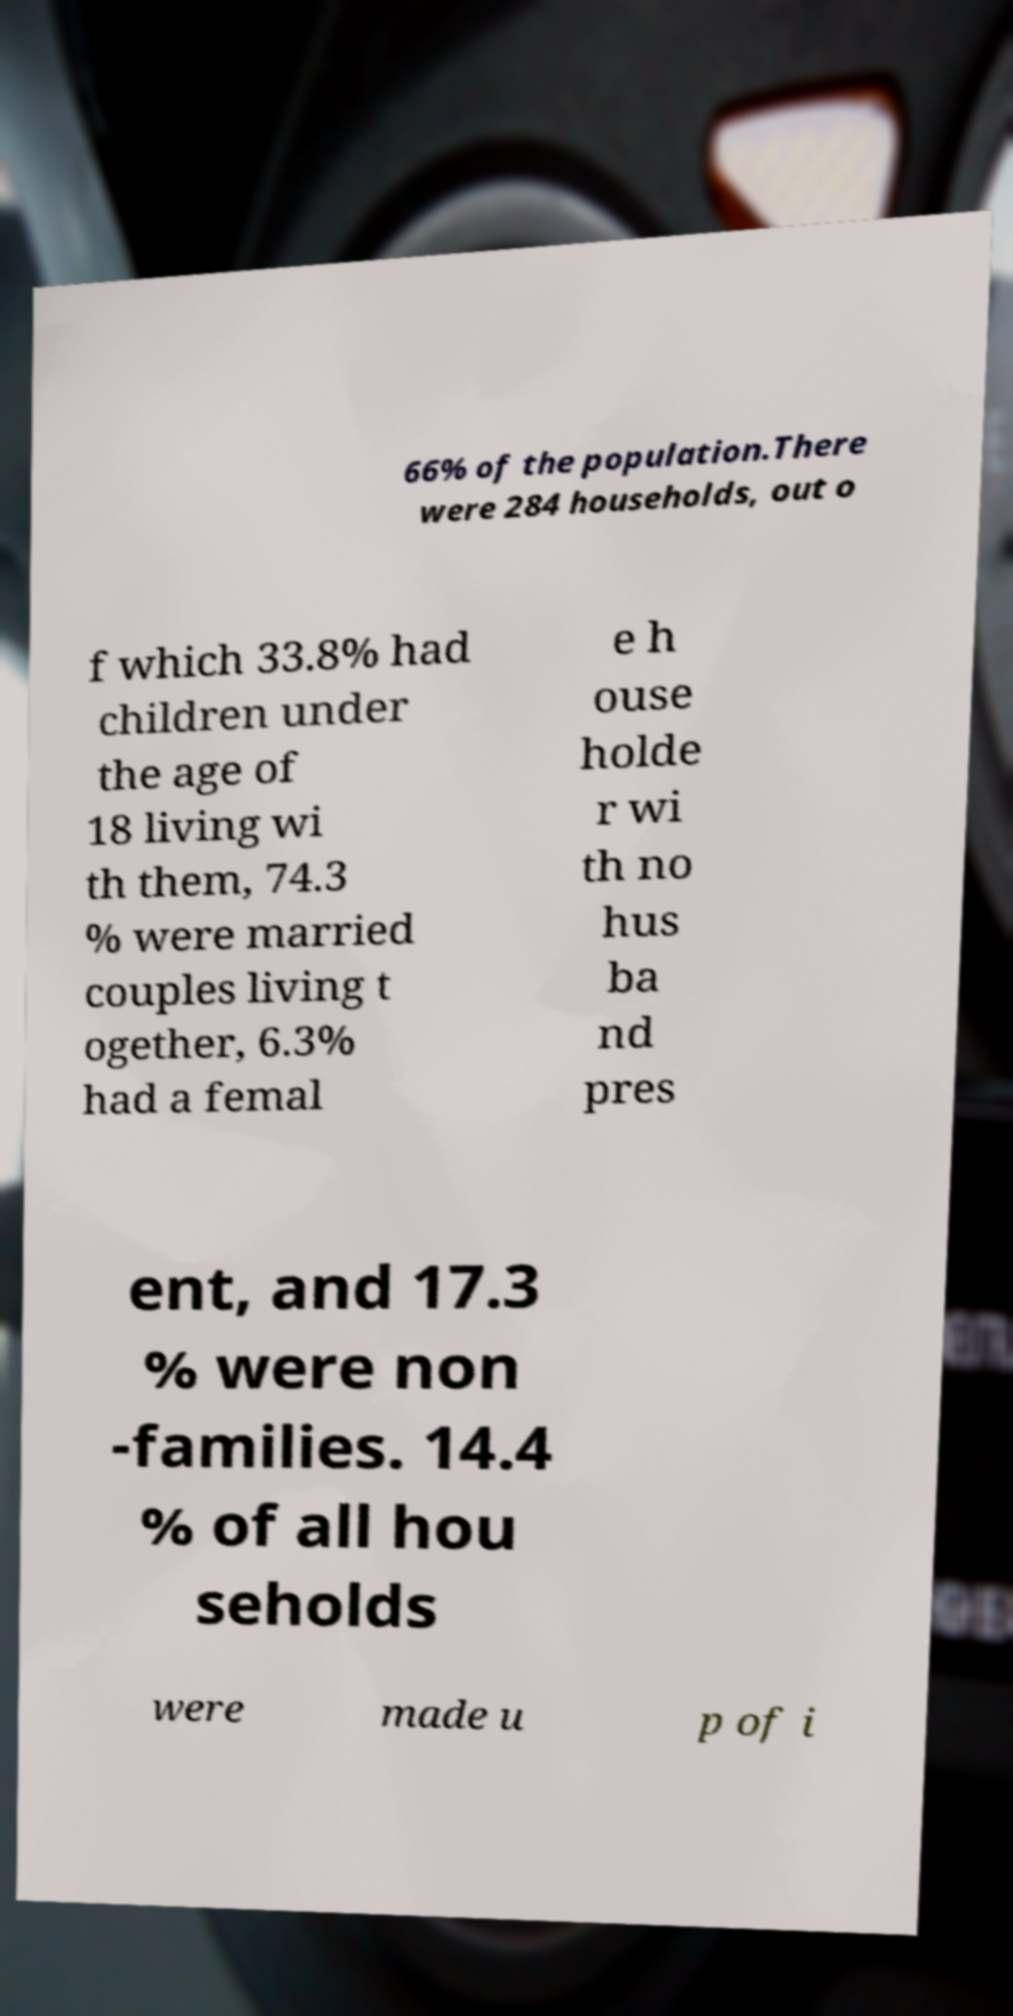Please read and relay the text visible in this image. What does it say? 66% of the population.There were 284 households, out o f which 33.8% had children under the age of 18 living wi th them, 74.3 % were married couples living t ogether, 6.3% had a femal e h ouse holde r wi th no hus ba nd pres ent, and 17.3 % were non -families. 14.4 % of all hou seholds were made u p of i 